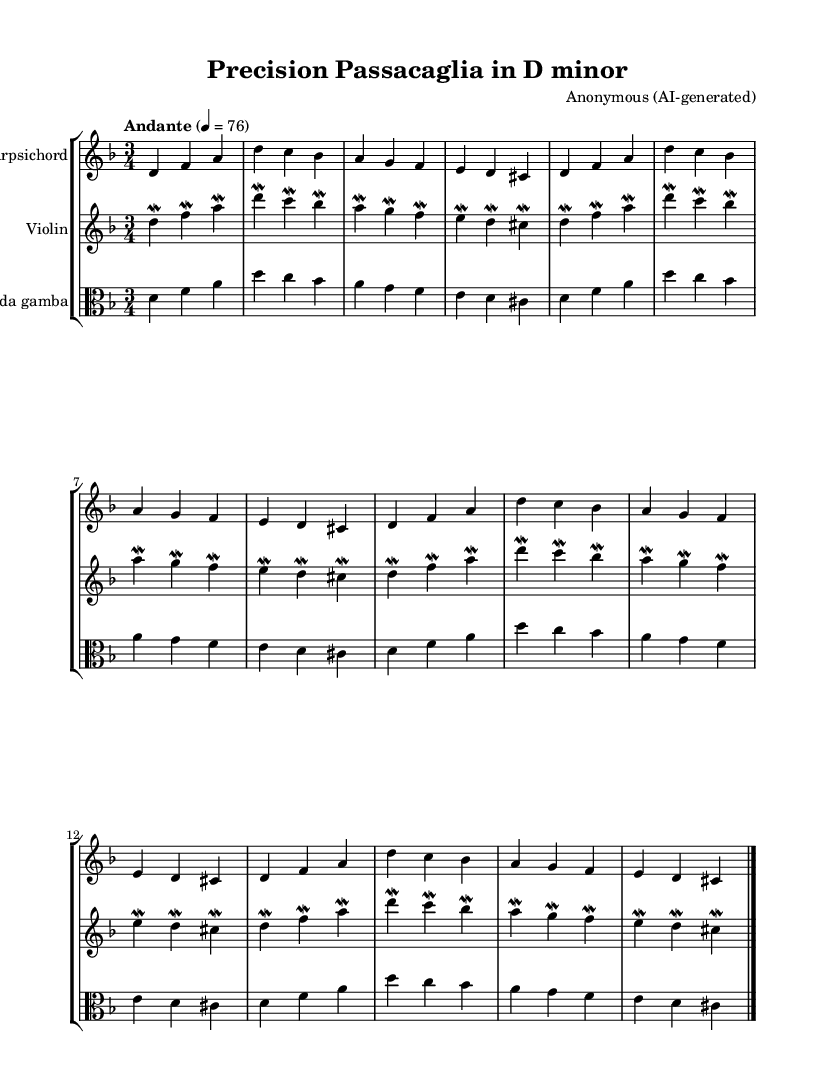What is the key signature of this music? The key signature is D minor, which features one flat (B flat). You can identify the key signature by looking at the beginning of the staff where the flats or sharps are notated. In this score, there is one flat, indicating D minor.
Answer: D minor What is the time signature of this music? The time signature is three-four, indicated by the numbers at the beginning of the piece. The top number (3) indicates there are three beats in a measure, and the bottom number (4) denotes that a quarter note gets one beat.
Answer: Three-four What is the tempo marking of this piece? The tempo marking is Andante, which suggests a moderately slow tempo. This marking is typically placed above the music staff and often includes a metronome marking; here, it's marked as 76 beats per minute.
Answer: Andante What instruments are featured in this chamber music? The instruments in this chamber music are a harpsichord, a violin, and a viola da gamba. You can tell this by the instrument names written above each staff, which specify what instrument is playing the written music.
Answer: Harpsichord, violin, viola da gamba Describe the texture of the music. The texture of this music is polyphonic, as it features multiple independent melodies being played simultaneously by different instruments. This characteristic is a hallmark of the Baroque period, where melodies intertwine and complement each other, creating a rich sound.
Answer: Polyphonic How many measures are repeated in this piece? The music includes a repeat of three measures, as indicated by the repeat unfolding notation. In the score, the sections after the first measure (where this specific melody line occurred) repeat three times exactly, creating a sense of continuity.
Answer: Three What specific ornamentation is used in the violin part? The ornamentation used in the violin part is mordents, indicated by the symbols placed before the notes. A mordent instructs the player to perform a rapid oscillation between the main note and the one above or below it quickly, adding expressiveness typical of Baroque music.
Answer: Mordents 